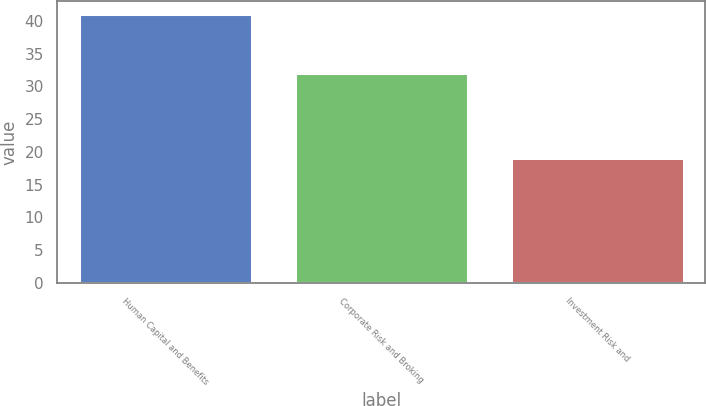<chart> <loc_0><loc_0><loc_500><loc_500><bar_chart><fcel>Human Capital and Benefits<fcel>Corporate Risk and Broking<fcel>Investment Risk and<nl><fcel>41<fcel>32<fcel>19<nl></chart> 